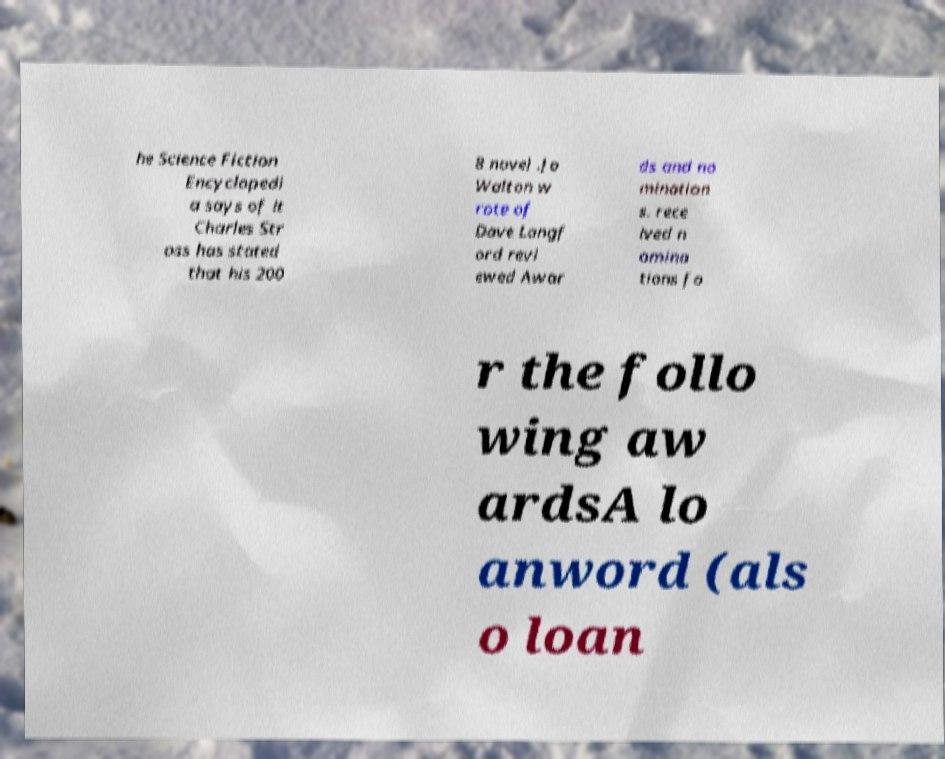What messages or text are displayed in this image? I need them in a readable, typed format. he Science Fiction Encyclopedi a says of it Charles Str oss has stated that his 200 8 novel .Jo Walton w rote of Dave Langf ord revi ewed Awar ds and no mination s. rece ived n omina tions fo r the follo wing aw ardsA lo anword (als o loan 